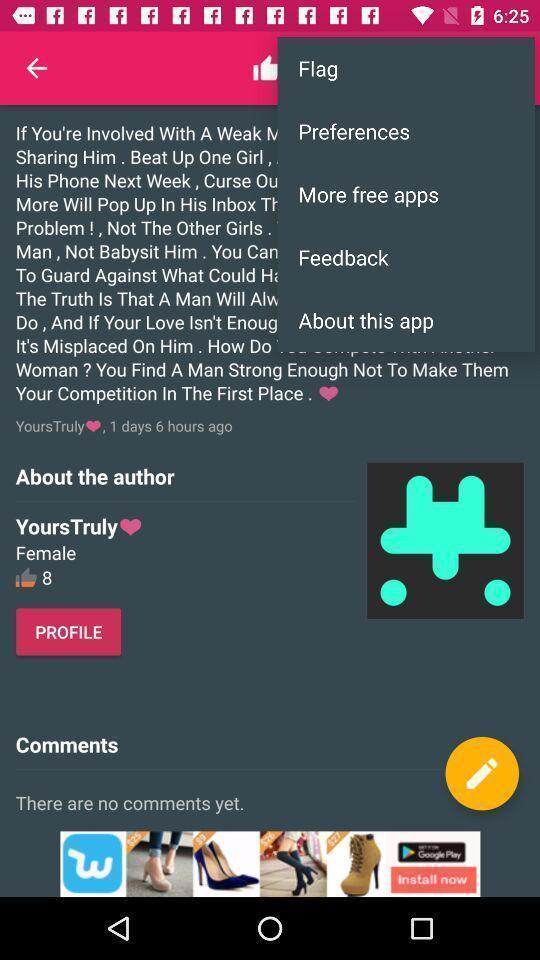Explain what's happening in this screen capture. Pop-up for flag preferences and feedback options on quotes app. 